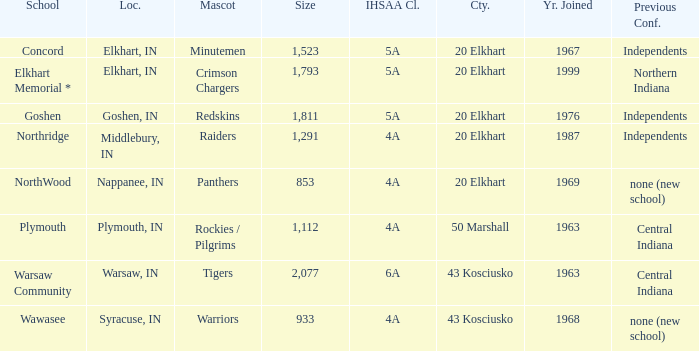What is the IHSAA class for the team located in Middlebury, IN? 4A. 